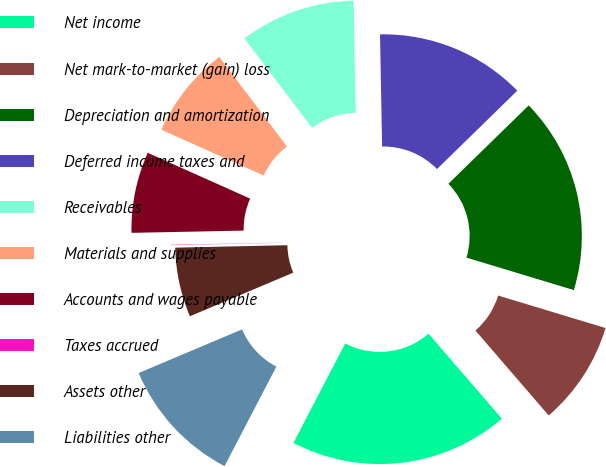Convert chart. <chart><loc_0><loc_0><loc_500><loc_500><pie_chart><fcel>Net income<fcel>Net mark-to-market (gain) loss<fcel>Depreciation and amortization<fcel>Deferred income taxes and<fcel>Receivables<fcel>Materials and supplies<fcel>Accounts and wages payable<fcel>Taxes accrued<fcel>Assets other<fcel>Liabilities other<nl><fcel>18.97%<fcel>9.0%<fcel>16.98%<fcel>12.99%<fcel>10.0%<fcel>8.01%<fcel>7.01%<fcel>0.03%<fcel>6.01%<fcel>11.0%<nl></chart> 